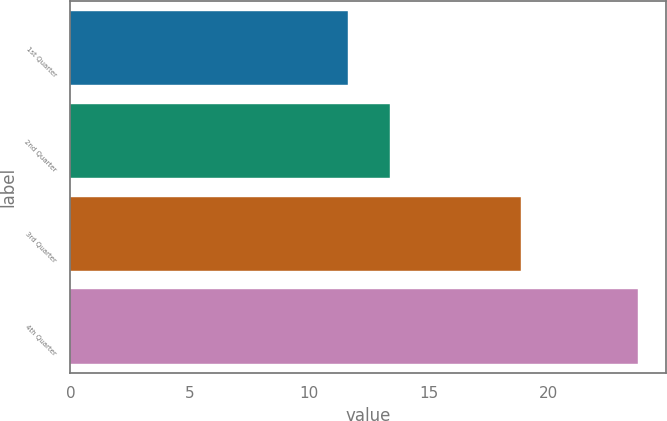Convert chart to OTSL. <chart><loc_0><loc_0><loc_500><loc_500><bar_chart><fcel>1st Quarter<fcel>2nd Quarter<fcel>3rd Quarter<fcel>4th Quarter<nl><fcel>11.62<fcel>13.36<fcel>18.85<fcel>23.75<nl></chart> 